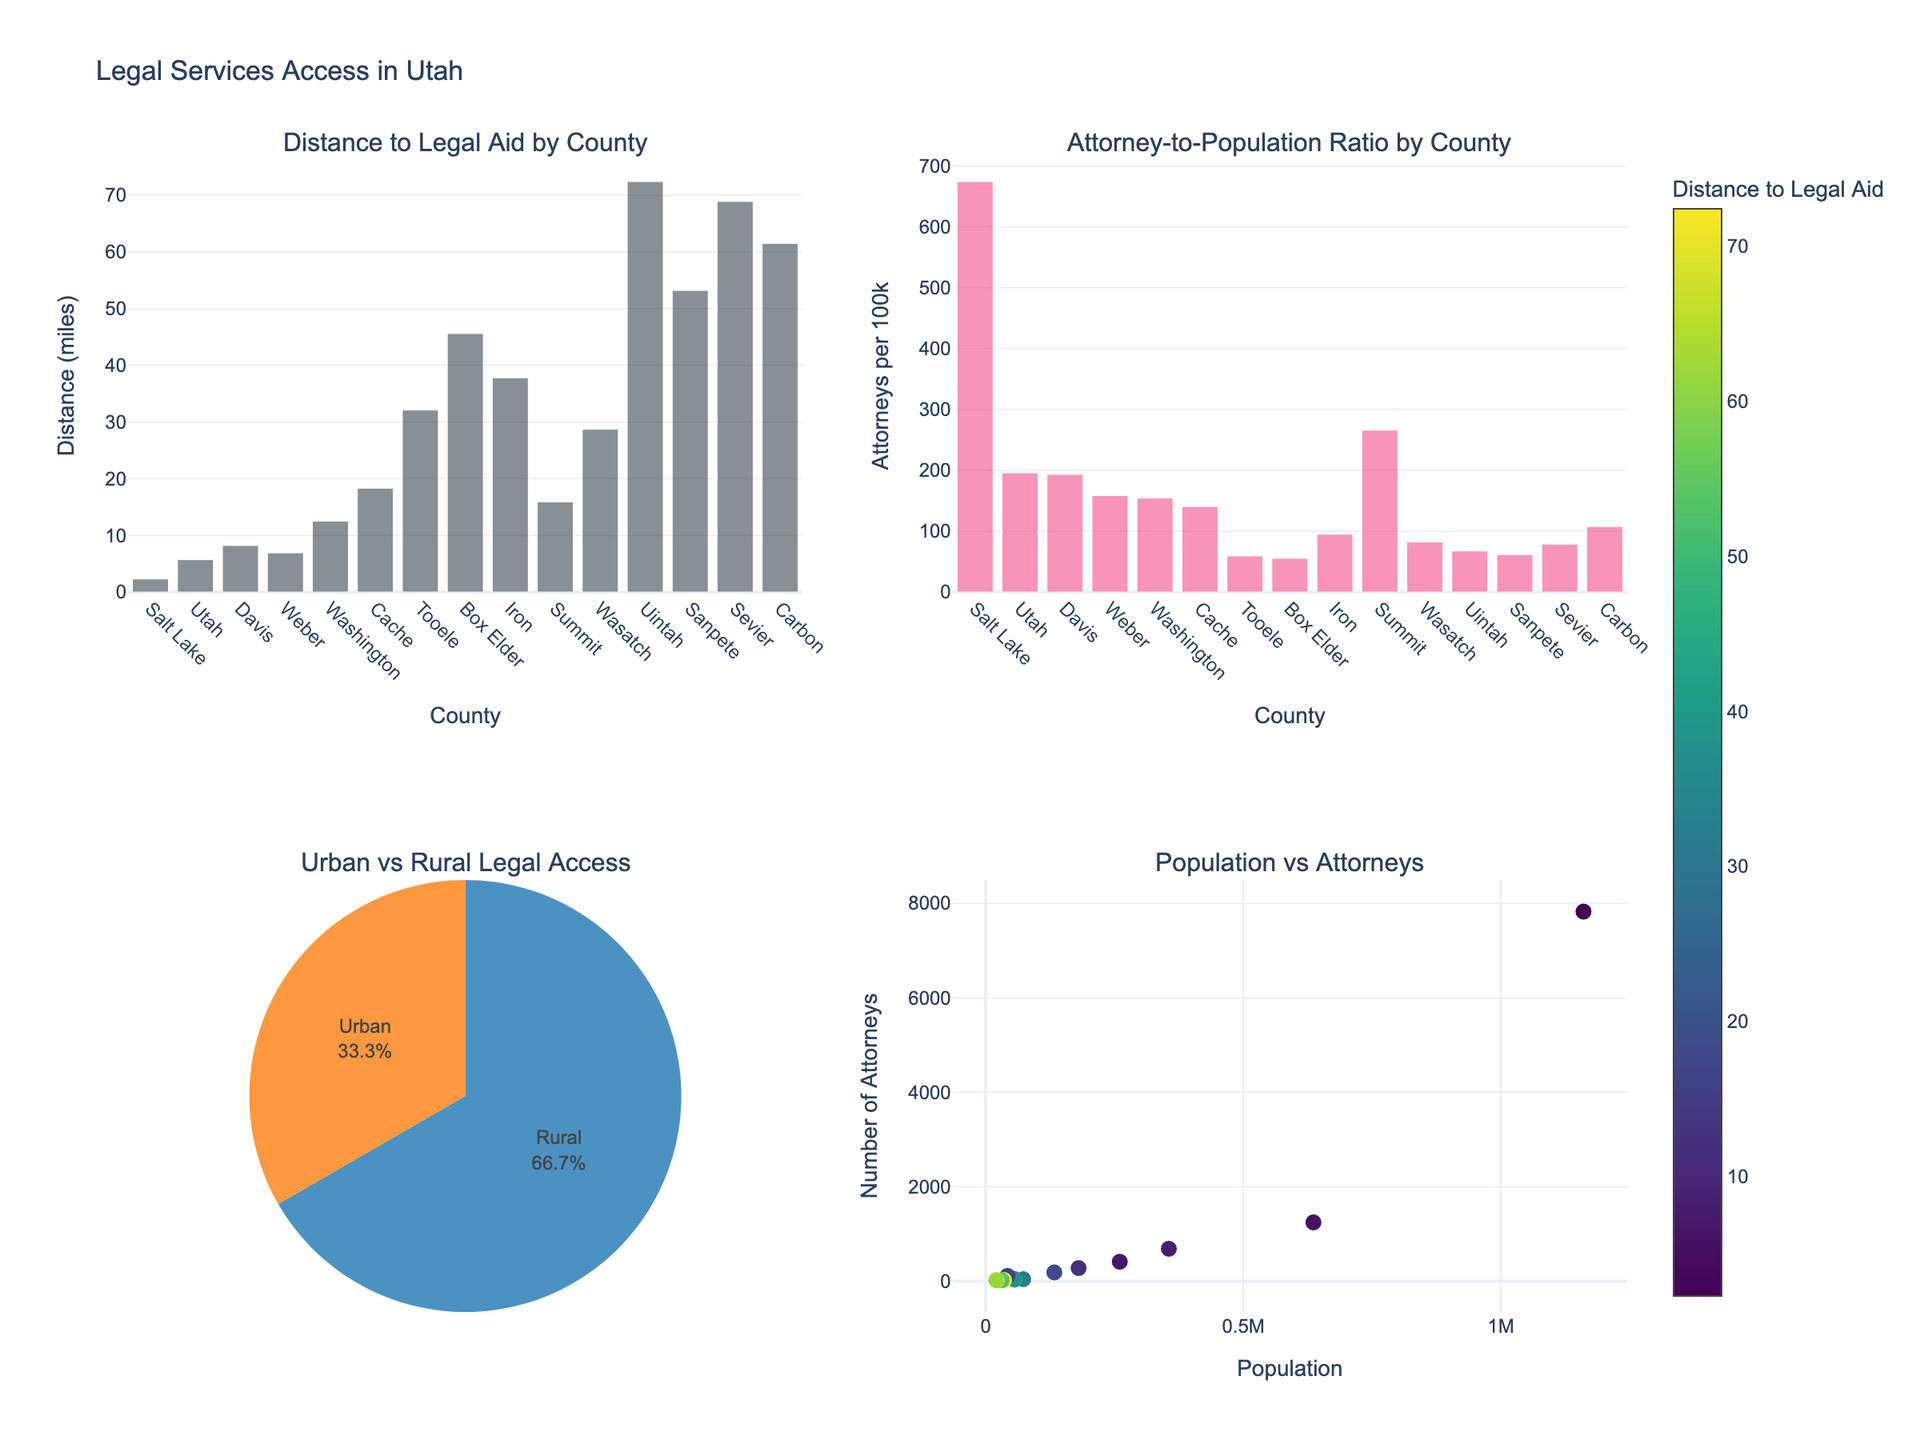What is the title of the figure? The title of the figure is located at the top and usually provides a summary of what the plot is about. By reading the title text, "Natural Disaster Scenarios: Fiction vs Reality," we can understand that the plot compares the frequency of natural disasters in eco-thrillers with their actual occurrences.
Answer: Natural Disaster Scenarios: Fiction vs Reality Which disaster has the highest frequency in eco-thrillers? To find this, you need to look at the left subplot and identify the bar that extends the furthest to the right. The disaster with the longest bar in the eco-thrillers subplot is "Mega-Tsunami" with a frequency of 8.
Answer: Mega-Tsunami How does the occurrence rate of category 5 hurricanes compare between eco-thrillers and actual data? Look at the corresponding bars for "Category 5 Hurricane" in both subplots. In eco-thrillers, it has a frequency of 6, and in the actual occurrence plot, it has a frequency of 5. Comparing the two shows that eco-thrillers slightly exaggerate the occurrence of Category 5 Hurricanes.
Answer: Eco-thrillers slightly exaggerate Calculate the difference in occurrence between the highest and lowest actual disaster frequencies. Identify the highest and lowest disaster frequencies from the actual occurrence subplot. The highest occurrence is "Massive Earthquake" with 3, and the lowest is "Sudden Ice Age" and "Magnetic Pole Reversal" both with 0. Subtract the lowest value from the highest: 3 - 0 = 3.
Answer: 3 What does the x-axis represent in the right subplot? The x-axis in the right subplot is labelled "Occurrence per Decade," indicating it shows how often each disaster occurs per decade in actual data.
Answer: Occurrence per Decade Which disaster is depicted as happening every decade in the actual data? Look for the disaster with a frequency of 1 in the actual occurrence subplot. "Global Pandemic" is shown occurring once per decade.
Answer: Global Pandemic Compute the ratio of the frequency of methane clathrate release scenarios in eco-thrillers to their actual occurrence. Find the frequency values for "Methane Clathrate Release" in both subplots. In eco-thrillers, it is 4, and the actual occurrence is 0.1. The ratio is calculated as 4 / 0.1 = 40.
Answer: 40 Explain why the x-axis scale in the actual occurrence plot might be log-scaled. Log scales are often used when dealing with data that varies across several orders of magnitude, to make the data visualization clearer and more readable. The actual occurrence rates vary significantly, from very rare events (e.g., 0.01 for Asteroid Impact) to more common ones (e.g., 5 for Category 5 Hurricane).
Answer: To handle wide range of values Compare the portrayal of supervolcano eruptions in eco-thrillers to their actual occurrences. In eco-thrillers, supervolcano eruptions have a frequency of 6. In the actual data, their occurrence is 0.05 per decade. This shows a significant exaggeration in eco-thrillers compared to real life.
Answer: Exaggeration in eco-thrillers 